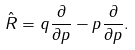<formula> <loc_0><loc_0><loc_500><loc_500>\hat { R } = q \frac { \partial } { \partial p } - p \frac { \partial } { \partial p } .</formula> 